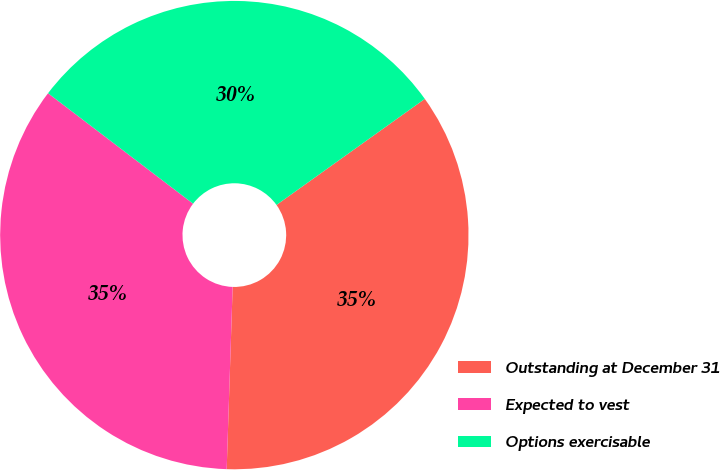Convert chart to OTSL. <chart><loc_0><loc_0><loc_500><loc_500><pie_chart><fcel>Outstanding at December 31<fcel>Expected to vest<fcel>Options exercisable<nl><fcel>35.4%<fcel>34.84%<fcel>29.76%<nl></chart> 